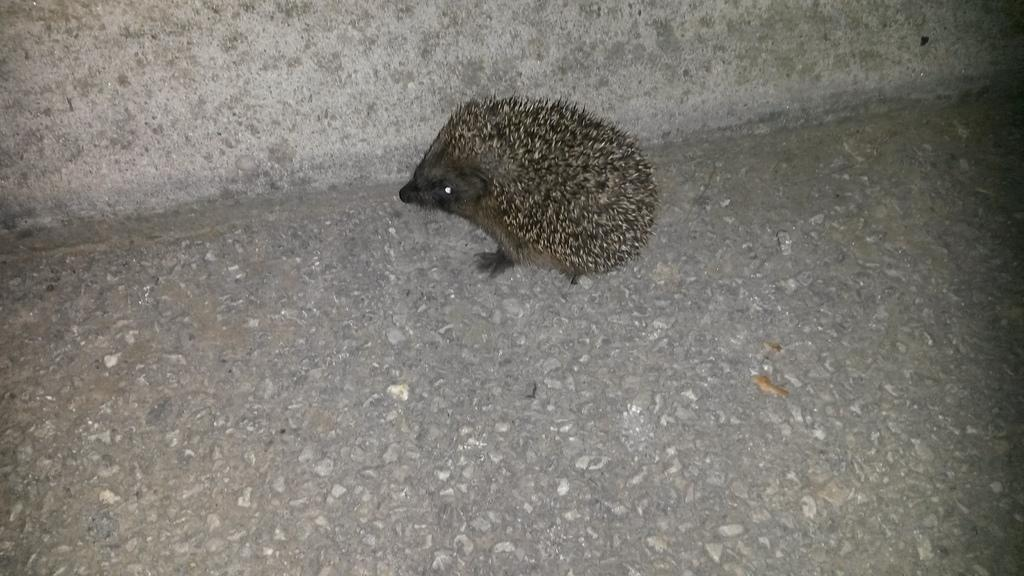What type of animal is in the center of the image? There is a domesticated hedgehog in the center of the image. Can you describe the position of the hedgehog in the image? The hedgehog is on the ground in the image. What type of patch can be seen on the hedgehog's back in the image? There is no patch visible on the hedgehog's back in the image. What sound does the hedgehog make in the image? Hedgehogs do not make sounds that can be heard in an image, as they are not capable of producing audible sounds in a still photograph. 